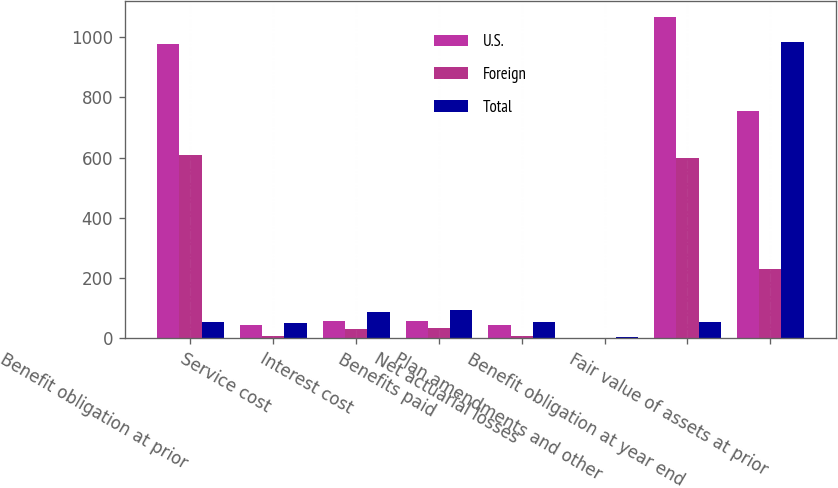Convert chart. <chart><loc_0><loc_0><loc_500><loc_500><stacked_bar_chart><ecel><fcel>Benefit obligation at prior<fcel>Service cost<fcel>Interest cost<fcel>Benefits paid<fcel>Net actuarial losses<fcel>Plan amendments and other<fcel>Benefit obligation at year end<fcel>Fair value of assets at prior<nl><fcel>U.S.<fcel>977.7<fcel>43.8<fcel>56.5<fcel>58.6<fcel>44.9<fcel>2.1<fcel>1066.4<fcel>755.7<nl><fcel>Foreign<fcel>610.1<fcel>7.1<fcel>29.5<fcel>34.9<fcel>9.2<fcel>1.4<fcel>597.6<fcel>228.7<nl><fcel>Total<fcel>55.3<fcel>50.9<fcel>86<fcel>93.5<fcel>54.1<fcel>3.5<fcel>55.3<fcel>984.4<nl></chart> 